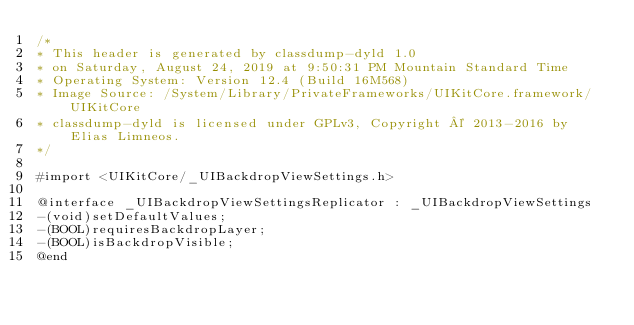<code> <loc_0><loc_0><loc_500><loc_500><_C_>/*
* This header is generated by classdump-dyld 1.0
* on Saturday, August 24, 2019 at 9:50:31 PM Mountain Standard Time
* Operating System: Version 12.4 (Build 16M568)
* Image Source: /System/Library/PrivateFrameworks/UIKitCore.framework/UIKitCore
* classdump-dyld is licensed under GPLv3, Copyright © 2013-2016 by Elias Limneos.
*/

#import <UIKitCore/_UIBackdropViewSettings.h>

@interface _UIBackdropViewSettingsReplicator : _UIBackdropViewSettings
-(void)setDefaultValues;
-(BOOL)requiresBackdropLayer;
-(BOOL)isBackdropVisible;
@end

</code> 